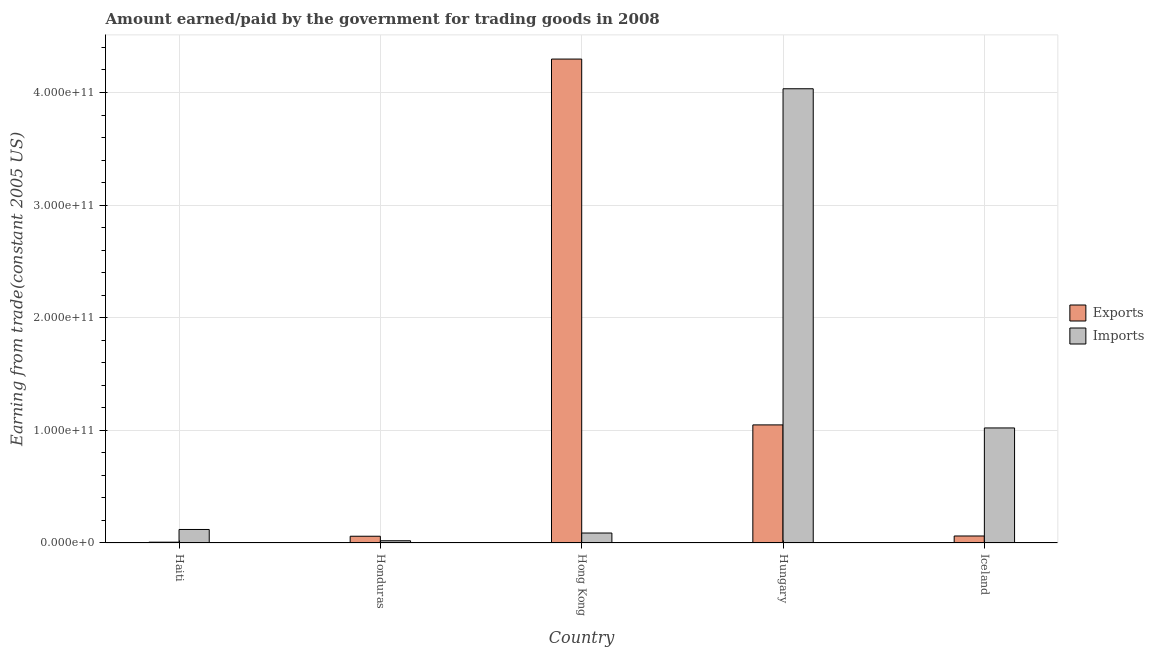How many different coloured bars are there?
Your answer should be compact. 2. How many groups of bars are there?
Keep it short and to the point. 5. Are the number of bars on each tick of the X-axis equal?
Make the answer very short. Yes. How many bars are there on the 3rd tick from the left?
Provide a short and direct response. 2. How many bars are there on the 3rd tick from the right?
Give a very brief answer. 2. What is the label of the 3rd group of bars from the left?
Provide a short and direct response. Hong Kong. What is the amount earned from exports in Hungary?
Your answer should be very brief. 1.05e+11. Across all countries, what is the maximum amount paid for imports?
Your response must be concise. 4.03e+11. Across all countries, what is the minimum amount paid for imports?
Your answer should be compact. 1.99e+09. In which country was the amount paid for imports maximum?
Your answer should be compact. Hungary. In which country was the amount earned from exports minimum?
Your answer should be very brief. Haiti. What is the total amount earned from exports in the graph?
Your answer should be very brief. 5.47e+11. What is the difference between the amount earned from exports in Hong Kong and that in Hungary?
Give a very brief answer. 3.25e+11. What is the difference between the amount paid for imports in Honduras and the amount earned from exports in Hungary?
Provide a succinct answer. -1.03e+11. What is the average amount earned from exports per country?
Provide a short and direct response. 1.09e+11. What is the difference between the amount earned from exports and amount paid for imports in Haiti?
Your answer should be very brief. -1.13e+1. What is the ratio of the amount earned from exports in Haiti to that in Iceland?
Give a very brief answer. 0.12. Is the amount paid for imports in Honduras less than that in Hong Kong?
Provide a short and direct response. Yes. What is the difference between the highest and the second highest amount paid for imports?
Make the answer very short. 3.01e+11. What is the difference between the highest and the lowest amount paid for imports?
Keep it short and to the point. 4.01e+11. In how many countries, is the amount earned from exports greater than the average amount earned from exports taken over all countries?
Your answer should be compact. 1. Is the sum of the amount earned from exports in Honduras and Hong Kong greater than the maximum amount paid for imports across all countries?
Provide a succinct answer. Yes. What does the 1st bar from the left in Iceland represents?
Offer a very short reply. Exports. What does the 2nd bar from the right in Haiti represents?
Give a very brief answer. Exports. How many bars are there?
Your answer should be very brief. 10. Are all the bars in the graph horizontal?
Make the answer very short. No. What is the difference between two consecutive major ticks on the Y-axis?
Make the answer very short. 1.00e+11. Are the values on the major ticks of Y-axis written in scientific E-notation?
Keep it short and to the point. Yes. How many legend labels are there?
Provide a succinct answer. 2. What is the title of the graph?
Your answer should be very brief. Amount earned/paid by the government for trading goods in 2008. Does "Females" appear as one of the legend labels in the graph?
Keep it short and to the point. No. What is the label or title of the Y-axis?
Make the answer very short. Earning from trade(constant 2005 US). What is the Earning from trade(constant 2005 US) of Exports in Haiti?
Offer a terse response. 7.15e+08. What is the Earning from trade(constant 2005 US) in Imports in Haiti?
Keep it short and to the point. 1.20e+1. What is the Earning from trade(constant 2005 US) in Exports in Honduras?
Provide a short and direct response. 5.99e+09. What is the Earning from trade(constant 2005 US) of Imports in Honduras?
Offer a terse response. 1.99e+09. What is the Earning from trade(constant 2005 US) of Exports in Hong Kong?
Keep it short and to the point. 4.30e+11. What is the Earning from trade(constant 2005 US) in Imports in Hong Kong?
Give a very brief answer. 8.85e+09. What is the Earning from trade(constant 2005 US) in Exports in Hungary?
Your response must be concise. 1.05e+11. What is the Earning from trade(constant 2005 US) of Imports in Hungary?
Keep it short and to the point. 4.03e+11. What is the Earning from trade(constant 2005 US) of Exports in Iceland?
Offer a very short reply. 6.21e+09. What is the Earning from trade(constant 2005 US) of Imports in Iceland?
Your answer should be very brief. 1.02e+11. Across all countries, what is the maximum Earning from trade(constant 2005 US) in Exports?
Offer a very short reply. 4.30e+11. Across all countries, what is the maximum Earning from trade(constant 2005 US) in Imports?
Make the answer very short. 4.03e+11. Across all countries, what is the minimum Earning from trade(constant 2005 US) in Exports?
Keep it short and to the point. 7.15e+08. Across all countries, what is the minimum Earning from trade(constant 2005 US) in Imports?
Provide a succinct answer. 1.99e+09. What is the total Earning from trade(constant 2005 US) of Exports in the graph?
Your answer should be very brief. 5.47e+11. What is the total Earning from trade(constant 2005 US) in Imports in the graph?
Give a very brief answer. 5.28e+11. What is the difference between the Earning from trade(constant 2005 US) of Exports in Haiti and that in Honduras?
Your answer should be very brief. -5.28e+09. What is the difference between the Earning from trade(constant 2005 US) of Imports in Haiti and that in Honduras?
Your answer should be compact. 1.00e+1. What is the difference between the Earning from trade(constant 2005 US) in Exports in Haiti and that in Hong Kong?
Offer a terse response. -4.29e+11. What is the difference between the Earning from trade(constant 2005 US) of Imports in Haiti and that in Hong Kong?
Provide a short and direct response. 3.15e+09. What is the difference between the Earning from trade(constant 2005 US) of Exports in Haiti and that in Hungary?
Your answer should be very brief. -1.04e+11. What is the difference between the Earning from trade(constant 2005 US) of Imports in Haiti and that in Hungary?
Provide a short and direct response. -3.91e+11. What is the difference between the Earning from trade(constant 2005 US) of Exports in Haiti and that in Iceland?
Offer a terse response. -5.49e+09. What is the difference between the Earning from trade(constant 2005 US) of Imports in Haiti and that in Iceland?
Your answer should be compact. -9.01e+1. What is the difference between the Earning from trade(constant 2005 US) of Exports in Honduras and that in Hong Kong?
Give a very brief answer. -4.24e+11. What is the difference between the Earning from trade(constant 2005 US) in Imports in Honduras and that in Hong Kong?
Ensure brevity in your answer.  -6.86e+09. What is the difference between the Earning from trade(constant 2005 US) in Exports in Honduras and that in Hungary?
Keep it short and to the point. -9.89e+1. What is the difference between the Earning from trade(constant 2005 US) in Imports in Honduras and that in Hungary?
Make the answer very short. -4.01e+11. What is the difference between the Earning from trade(constant 2005 US) in Exports in Honduras and that in Iceland?
Make the answer very short. -2.15e+08. What is the difference between the Earning from trade(constant 2005 US) of Imports in Honduras and that in Iceland?
Your response must be concise. -1.00e+11. What is the difference between the Earning from trade(constant 2005 US) in Exports in Hong Kong and that in Hungary?
Ensure brevity in your answer.  3.25e+11. What is the difference between the Earning from trade(constant 2005 US) of Imports in Hong Kong and that in Hungary?
Provide a short and direct response. -3.94e+11. What is the difference between the Earning from trade(constant 2005 US) in Exports in Hong Kong and that in Iceland?
Ensure brevity in your answer.  4.23e+11. What is the difference between the Earning from trade(constant 2005 US) in Imports in Hong Kong and that in Iceland?
Your response must be concise. -9.33e+1. What is the difference between the Earning from trade(constant 2005 US) of Exports in Hungary and that in Iceland?
Offer a very short reply. 9.86e+1. What is the difference between the Earning from trade(constant 2005 US) of Imports in Hungary and that in Iceland?
Provide a succinct answer. 3.01e+11. What is the difference between the Earning from trade(constant 2005 US) in Exports in Haiti and the Earning from trade(constant 2005 US) in Imports in Honduras?
Your answer should be compact. -1.28e+09. What is the difference between the Earning from trade(constant 2005 US) of Exports in Haiti and the Earning from trade(constant 2005 US) of Imports in Hong Kong?
Ensure brevity in your answer.  -8.14e+09. What is the difference between the Earning from trade(constant 2005 US) of Exports in Haiti and the Earning from trade(constant 2005 US) of Imports in Hungary?
Your response must be concise. -4.03e+11. What is the difference between the Earning from trade(constant 2005 US) of Exports in Haiti and the Earning from trade(constant 2005 US) of Imports in Iceland?
Keep it short and to the point. -1.01e+11. What is the difference between the Earning from trade(constant 2005 US) in Exports in Honduras and the Earning from trade(constant 2005 US) in Imports in Hong Kong?
Ensure brevity in your answer.  -2.86e+09. What is the difference between the Earning from trade(constant 2005 US) of Exports in Honduras and the Earning from trade(constant 2005 US) of Imports in Hungary?
Provide a succinct answer. -3.97e+11. What is the difference between the Earning from trade(constant 2005 US) in Exports in Honduras and the Earning from trade(constant 2005 US) in Imports in Iceland?
Offer a terse response. -9.62e+1. What is the difference between the Earning from trade(constant 2005 US) in Exports in Hong Kong and the Earning from trade(constant 2005 US) in Imports in Hungary?
Make the answer very short. 2.64e+1. What is the difference between the Earning from trade(constant 2005 US) of Exports in Hong Kong and the Earning from trade(constant 2005 US) of Imports in Iceland?
Provide a short and direct response. 3.28e+11. What is the difference between the Earning from trade(constant 2005 US) in Exports in Hungary and the Earning from trade(constant 2005 US) in Imports in Iceland?
Offer a terse response. 2.71e+09. What is the average Earning from trade(constant 2005 US) of Exports per country?
Your response must be concise. 1.09e+11. What is the average Earning from trade(constant 2005 US) in Imports per country?
Your answer should be compact. 1.06e+11. What is the difference between the Earning from trade(constant 2005 US) in Exports and Earning from trade(constant 2005 US) in Imports in Haiti?
Your response must be concise. -1.13e+1. What is the difference between the Earning from trade(constant 2005 US) in Exports and Earning from trade(constant 2005 US) in Imports in Honduras?
Keep it short and to the point. 4.00e+09. What is the difference between the Earning from trade(constant 2005 US) in Exports and Earning from trade(constant 2005 US) in Imports in Hong Kong?
Your response must be concise. 4.21e+11. What is the difference between the Earning from trade(constant 2005 US) in Exports and Earning from trade(constant 2005 US) in Imports in Hungary?
Make the answer very short. -2.98e+11. What is the difference between the Earning from trade(constant 2005 US) of Exports and Earning from trade(constant 2005 US) of Imports in Iceland?
Ensure brevity in your answer.  -9.59e+1. What is the ratio of the Earning from trade(constant 2005 US) of Exports in Haiti to that in Honduras?
Your answer should be compact. 0.12. What is the ratio of the Earning from trade(constant 2005 US) in Imports in Haiti to that in Honduras?
Provide a short and direct response. 6.02. What is the ratio of the Earning from trade(constant 2005 US) of Exports in Haiti to that in Hong Kong?
Offer a terse response. 0. What is the ratio of the Earning from trade(constant 2005 US) in Imports in Haiti to that in Hong Kong?
Your answer should be compact. 1.36. What is the ratio of the Earning from trade(constant 2005 US) of Exports in Haiti to that in Hungary?
Provide a short and direct response. 0.01. What is the ratio of the Earning from trade(constant 2005 US) of Imports in Haiti to that in Hungary?
Give a very brief answer. 0.03. What is the ratio of the Earning from trade(constant 2005 US) in Exports in Haiti to that in Iceland?
Your answer should be very brief. 0.12. What is the ratio of the Earning from trade(constant 2005 US) in Imports in Haiti to that in Iceland?
Ensure brevity in your answer.  0.12. What is the ratio of the Earning from trade(constant 2005 US) in Exports in Honduras to that in Hong Kong?
Keep it short and to the point. 0.01. What is the ratio of the Earning from trade(constant 2005 US) of Imports in Honduras to that in Hong Kong?
Your answer should be very brief. 0.23. What is the ratio of the Earning from trade(constant 2005 US) in Exports in Honduras to that in Hungary?
Your answer should be compact. 0.06. What is the ratio of the Earning from trade(constant 2005 US) in Imports in Honduras to that in Hungary?
Make the answer very short. 0. What is the ratio of the Earning from trade(constant 2005 US) of Exports in Honduras to that in Iceland?
Provide a succinct answer. 0.97. What is the ratio of the Earning from trade(constant 2005 US) in Imports in Honduras to that in Iceland?
Your response must be concise. 0.02. What is the ratio of the Earning from trade(constant 2005 US) in Exports in Hong Kong to that in Hungary?
Your answer should be very brief. 4.1. What is the ratio of the Earning from trade(constant 2005 US) in Imports in Hong Kong to that in Hungary?
Provide a succinct answer. 0.02. What is the ratio of the Earning from trade(constant 2005 US) in Exports in Hong Kong to that in Iceland?
Provide a succinct answer. 69.21. What is the ratio of the Earning from trade(constant 2005 US) in Imports in Hong Kong to that in Iceland?
Make the answer very short. 0.09. What is the ratio of the Earning from trade(constant 2005 US) in Exports in Hungary to that in Iceland?
Ensure brevity in your answer.  16.89. What is the ratio of the Earning from trade(constant 2005 US) in Imports in Hungary to that in Iceland?
Give a very brief answer. 3.95. What is the difference between the highest and the second highest Earning from trade(constant 2005 US) in Exports?
Your answer should be compact. 3.25e+11. What is the difference between the highest and the second highest Earning from trade(constant 2005 US) in Imports?
Provide a succinct answer. 3.01e+11. What is the difference between the highest and the lowest Earning from trade(constant 2005 US) of Exports?
Offer a terse response. 4.29e+11. What is the difference between the highest and the lowest Earning from trade(constant 2005 US) of Imports?
Provide a succinct answer. 4.01e+11. 